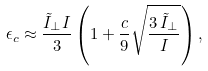<formula> <loc_0><loc_0><loc_500><loc_500>\epsilon _ { c } \approx \frac { { \tilde { I } } _ { \perp } I } { 3 } \left ( 1 + \frac { c } { 9 } \sqrt { \frac { 3 \, { \tilde { I } } _ { \perp } } { I } } \right ) ,</formula> 